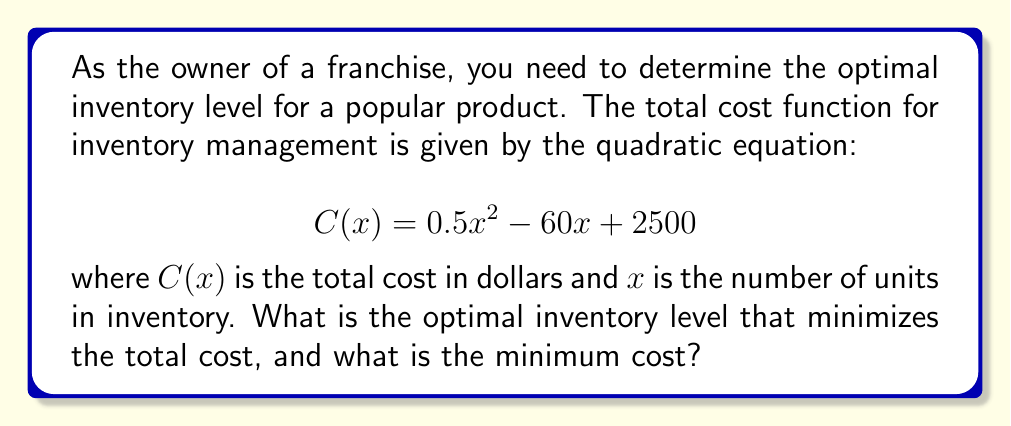Solve this math problem. To find the optimal inventory level, we need to determine the minimum point of the quadratic function. This can be done by following these steps:

1. The quadratic function is in the form $ax^2 + bx + c$, where:
   $a = 0.5$, $b = -60$, and $c = 2500$

2. For a quadratic function, the x-coordinate of the vertex (which represents the optimal inventory level) is given by the formula:

   $$ x = -\frac{b}{2a} $$

3. Substituting the values:

   $$ x = -\frac{-60}{2(0.5)} = \frac{60}{1} = 60 $$

4. Therefore, the optimal inventory level is 60 units.

5. To find the minimum cost, we substitute this x-value back into the original function:

   $$ C(60) = 0.5(60)^2 - 60(60) + 2500 $$
   $$ = 0.5(3600) - 3600 + 2500 $$
   $$ = 1800 - 3600 + 2500 $$
   $$ = 700 $$

Thus, the minimum cost is $700.
Answer: The optimal inventory level is 60 units, and the minimum total cost is $700. 